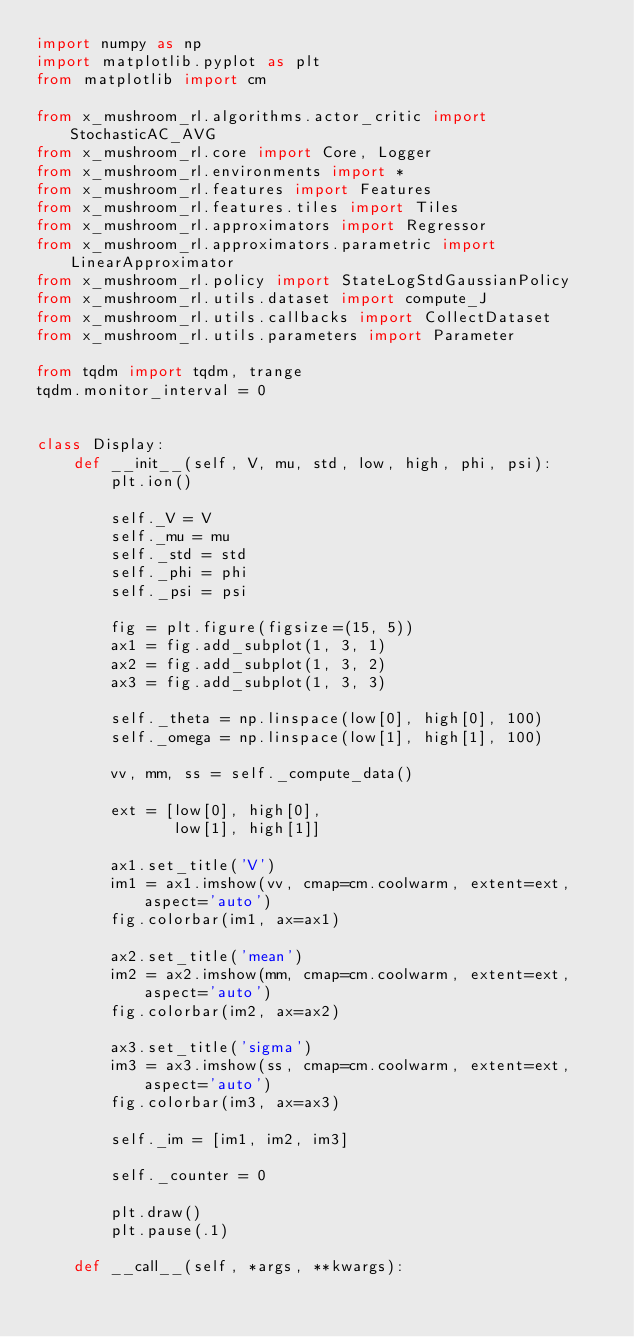Convert code to text. <code><loc_0><loc_0><loc_500><loc_500><_Python_>import numpy as np
import matplotlib.pyplot as plt
from matplotlib import cm

from x_mushroom_rl.algorithms.actor_critic import StochasticAC_AVG
from x_mushroom_rl.core import Core, Logger
from x_mushroom_rl.environments import *
from x_mushroom_rl.features import Features
from x_mushroom_rl.features.tiles import Tiles
from x_mushroom_rl.approximators import Regressor
from x_mushroom_rl.approximators.parametric import LinearApproximator
from x_mushroom_rl.policy import StateLogStdGaussianPolicy
from x_mushroom_rl.utils.dataset import compute_J
from x_mushroom_rl.utils.callbacks import CollectDataset
from x_mushroom_rl.utils.parameters import Parameter

from tqdm import tqdm, trange
tqdm.monitor_interval = 0


class Display:
    def __init__(self, V, mu, std, low, high, phi, psi):
        plt.ion()

        self._V = V
        self._mu = mu
        self._std = std
        self._phi = phi
        self._psi = psi

        fig = plt.figure(figsize=(15, 5))
        ax1 = fig.add_subplot(1, 3, 1)
        ax2 = fig.add_subplot(1, 3, 2)
        ax3 = fig.add_subplot(1, 3, 3)

        self._theta = np.linspace(low[0], high[0], 100)
        self._omega = np.linspace(low[1], high[1], 100)

        vv, mm, ss = self._compute_data()

        ext = [low[0], high[0],
               low[1], high[1]]

        ax1.set_title('V')
        im1 = ax1.imshow(vv, cmap=cm.coolwarm, extent=ext, aspect='auto')
        fig.colorbar(im1, ax=ax1)

        ax2.set_title('mean')
        im2 = ax2.imshow(mm, cmap=cm.coolwarm, extent=ext, aspect='auto')
        fig.colorbar(im2, ax=ax2)

        ax3.set_title('sigma')
        im3 = ax3.imshow(ss, cmap=cm.coolwarm, extent=ext, aspect='auto')
        fig.colorbar(im3, ax=ax3)

        self._im = [im1, im2, im3]

        self._counter = 0

        plt.draw()
        plt.pause(.1)

    def __call__(self, *args, **kwargs):</code> 